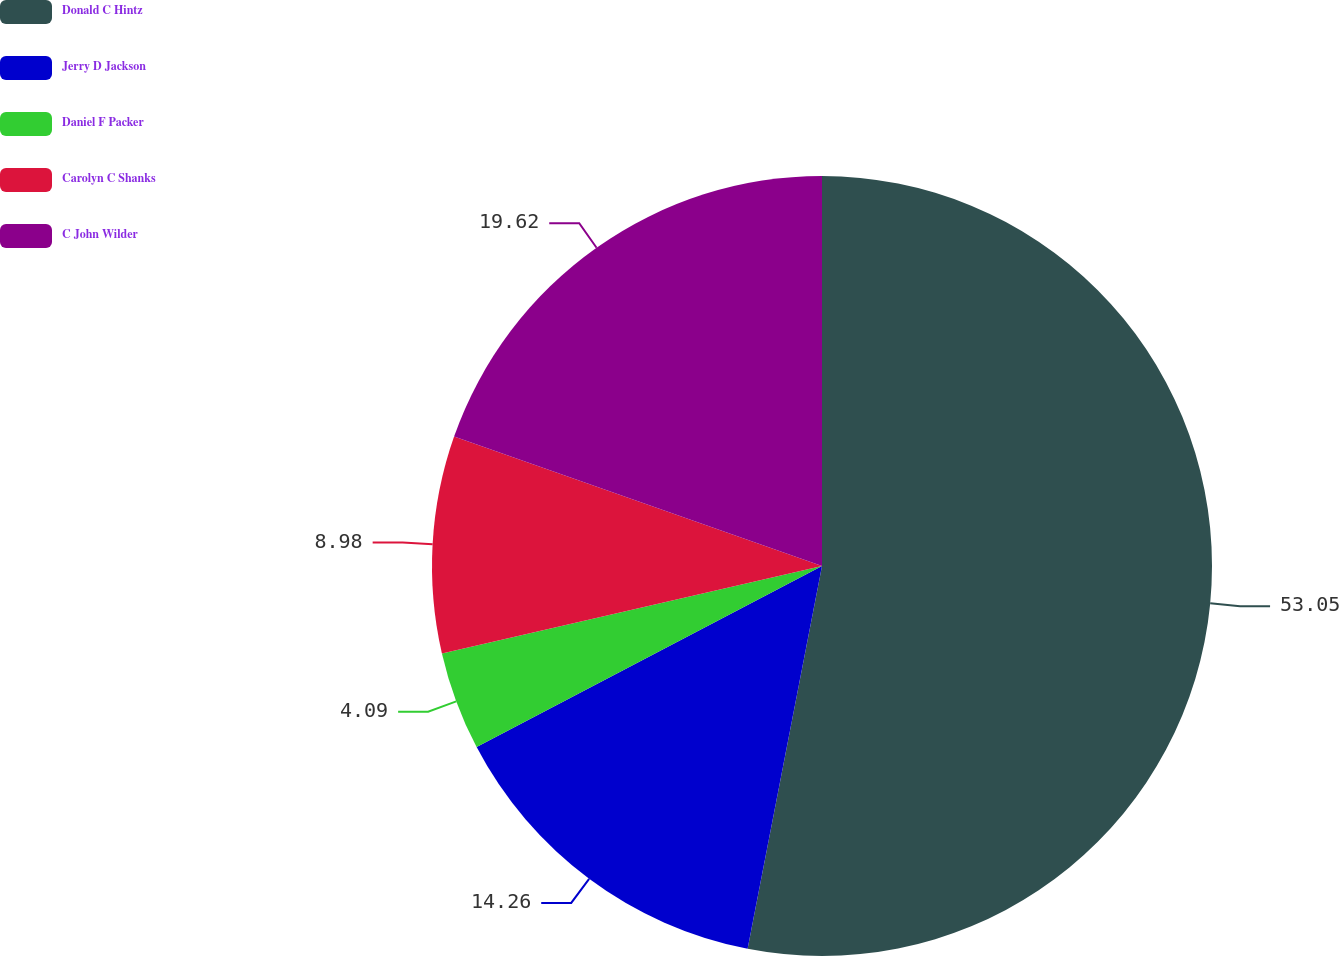Convert chart to OTSL. <chart><loc_0><loc_0><loc_500><loc_500><pie_chart><fcel>Donald C Hintz<fcel>Jerry D Jackson<fcel>Daniel F Packer<fcel>Carolyn C Shanks<fcel>C John Wilder<nl><fcel>53.06%<fcel>14.26%<fcel>4.09%<fcel>8.98%<fcel>19.62%<nl></chart> 